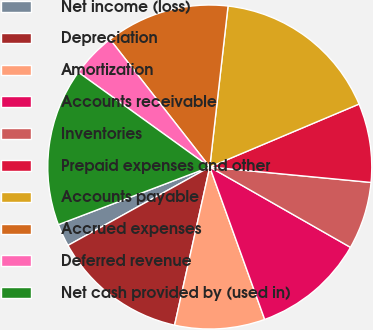<chart> <loc_0><loc_0><loc_500><loc_500><pie_chart><fcel>Net income (loss)<fcel>Depreciation<fcel>Amortization<fcel>Accounts receivable<fcel>Inventories<fcel>Prepaid expenses and other<fcel>Accounts payable<fcel>Accrued expenses<fcel>Deferred revenue<fcel>Net cash provided by (used in)<nl><fcel>2.25%<fcel>13.48%<fcel>8.99%<fcel>11.24%<fcel>6.74%<fcel>7.87%<fcel>16.85%<fcel>12.36%<fcel>4.5%<fcel>15.73%<nl></chart> 